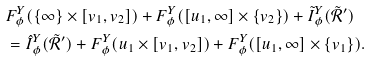Convert formula to latex. <formula><loc_0><loc_0><loc_500><loc_500>& F ^ { Y } _ { \phi } ( \{ \infty \} \times [ v _ { 1 } , v _ { 2 } ] ) + F ^ { Y } _ { \phi } ( [ u _ { 1 } , \infty ] \times \{ v _ { 2 } \} ) + \tilde { I } ^ { Y } _ { \phi } ( \tilde { \mathcal { R } } ^ { \prime } ) \\ & = \hat { I } ^ { Y } _ { \phi } ( \tilde { \mathcal { R } } ^ { \prime } ) + F ^ { Y } _ { \phi } ( u _ { 1 } \times [ v _ { 1 } , v _ { 2 } ] ) + F ^ { Y } _ { \phi } ( [ u _ { 1 } , \infty ] \times \{ v _ { 1 } \} ) .</formula> 